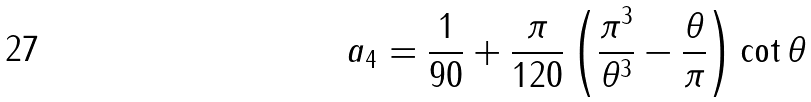<formula> <loc_0><loc_0><loc_500><loc_500>a _ { 4 } = \frac { 1 } { 9 0 } + \frac { \pi } { 1 2 0 } \left ( \frac { \pi ^ { 3 } } { \theta ^ { 3 } } - \frac { \theta } { \pi } \right ) \cot \theta</formula> 